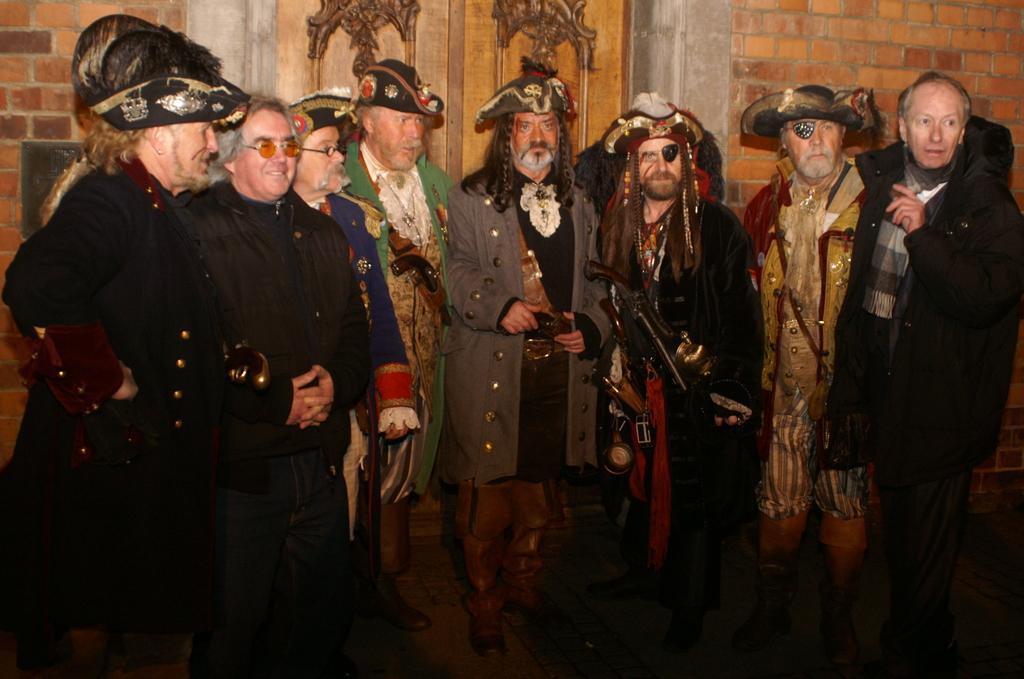How would you summarize this image in a sentence or two? In this image there are people standing there costumes, in the background there is a wall. 